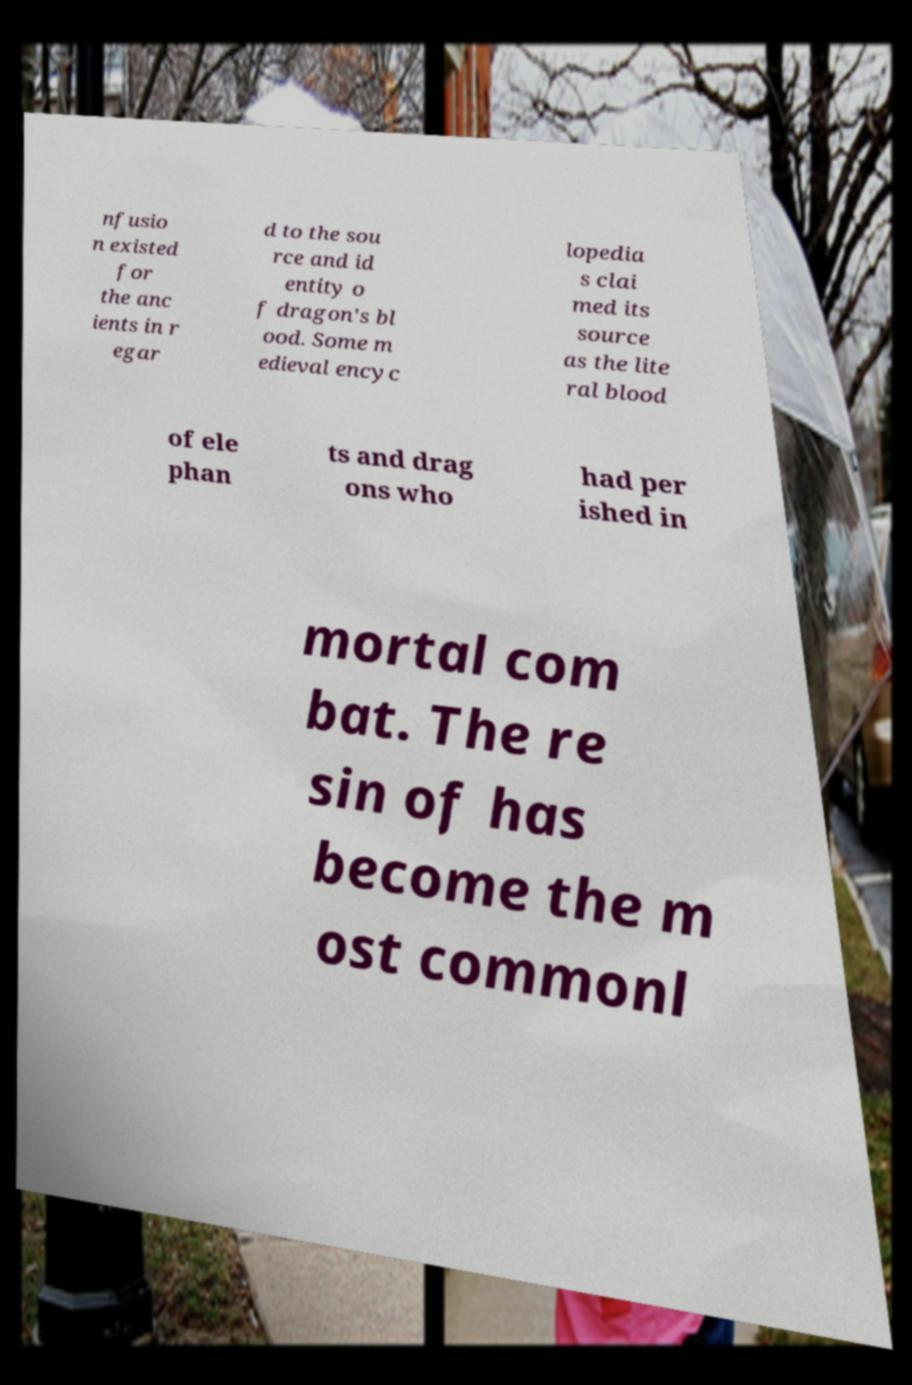Could you extract and type out the text from this image? nfusio n existed for the anc ients in r egar d to the sou rce and id entity o f dragon's bl ood. Some m edieval encyc lopedia s clai med its source as the lite ral blood of ele phan ts and drag ons who had per ished in mortal com bat. The re sin of has become the m ost commonl 